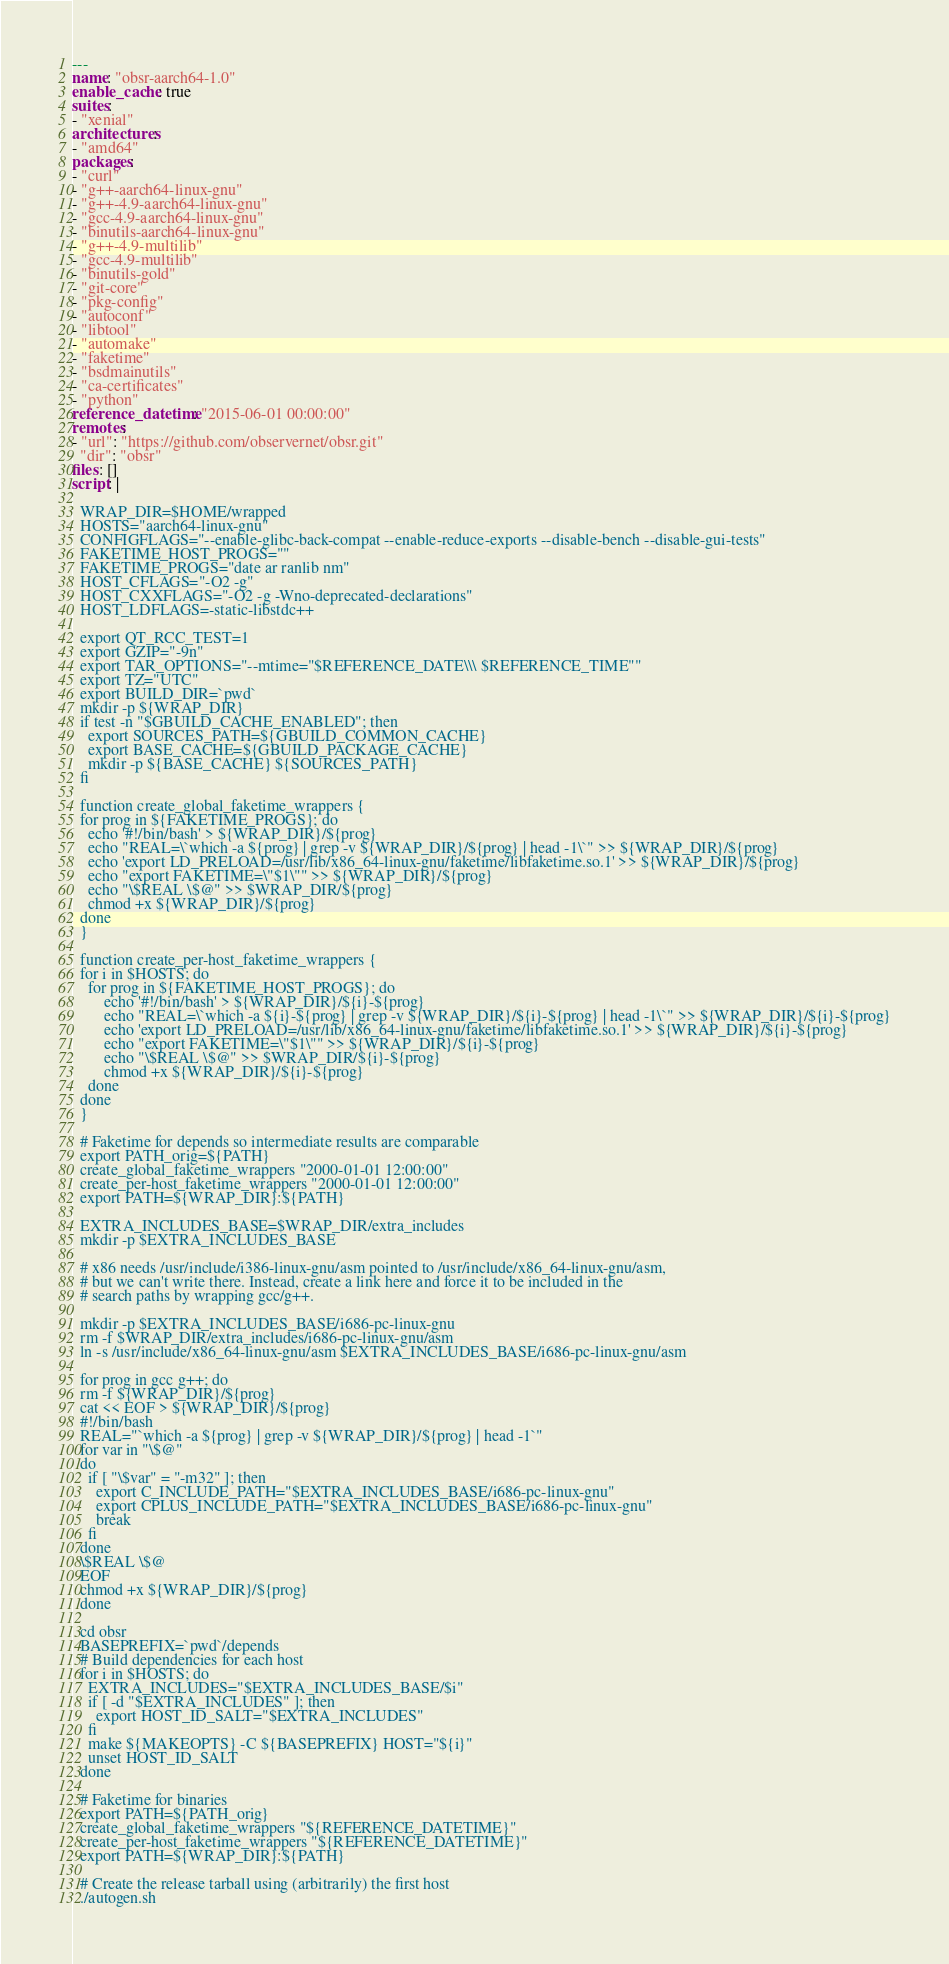<code> <loc_0><loc_0><loc_500><loc_500><_YAML_>---
name: "obsr-aarch64-1.0"
enable_cache: true
suites:
- "xenial"
architectures:
- "amd64"
packages:
- "curl"
- "g++-aarch64-linux-gnu"
- "g++-4.9-aarch64-linux-gnu"
- "gcc-4.9-aarch64-linux-gnu"
- "binutils-aarch64-linux-gnu"
- "g++-4.9-multilib"
- "gcc-4.9-multilib"
- "binutils-gold"
- "git-core"
- "pkg-config"
- "autoconf"
- "libtool"
- "automake"
- "faketime"
- "bsdmainutils"
- "ca-certificates"
- "python"
reference_datetime: "2015-06-01 00:00:00"
remotes:
- "url": "https://github.com/observernet/obsr.git"
  "dir": "obsr"
files: []
script: |

  WRAP_DIR=$HOME/wrapped
  HOSTS="aarch64-linux-gnu"
  CONFIGFLAGS="--enable-glibc-back-compat --enable-reduce-exports --disable-bench --disable-gui-tests"
  FAKETIME_HOST_PROGS=""
  FAKETIME_PROGS="date ar ranlib nm"
  HOST_CFLAGS="-O2 -g"
  HOST_CXXFLAGS="-O2 -g -Wno-deprecated-declarations"
  HOST_LDFLAGS=-static-libstdc++

  export QT_RCC_TEST=1
  export GZIP="-9n"
  export TAR_OPTIONS="--mtime="$REFERENCE_DATE\\\ $REFERENCE_TIME""
  export TZ="UTC"
  export BUILD_DIR=`pwd`
  mkdir -p ${WRAP_DIR}
  if test -n "$GBUILD_CACHE_ENABLED"; then
    export SOURCES_PATH=${GBUILD_COMMON_CACHE}
    export BASE_CACHE=${GBUILD_PACKAGE_CACHE}
    mkdir -p ${BASE_CACHE} ${SOURCES_PATH}
  fi

  function create_global_faketime_wrappers {
  for prog in ${FAKETIME_PROGS}; do
    echo '#!/bin/bash' > ${WRAP_DIR}/${prog}
    echo "REAL=\`which -a ${prog} | grep -v ${WRAP_DIR}/${prog} | head -1\`" >> ${WRAP_DIR}/${prog}
    echo 'export LD_PRELOAD=/usr/lib/x86_64-linux-gnu/faketime/libfaketime.so.1' >> ${WRAP_DIR}/${prog}
    echo "export FAKETIME=\"$1\"" >> ${WRAP_DIR}/${prog}
    echo "\$REAL \$@" >> $WRAP_DIR/${prog}
    chmod +x ${WRAP_DIR}/${prog}
  done
  }

  function create_per-host_faketime_wrappers {
  for i in $HOSTS; do
    for prog in ${FAKETIME_HOST_PROGS}; do
        echo '#!/bin/bash' > ${WRAP_DIR}/${i}-${prog}
        echo "REAL=\`which -a ${i}-${prog} | grep -v ${WRAP_DIR}/${i}-${prog} | head -1\`" >> ${WRAP_DIR}/${i}-${prog}
        echo 'export LD_PRELOAD=/usr/lib/x86_64-linux-gnu/faketime/libfaketime.so.1' >> ${WRAP_DIR}/${i}-${prog}
        echo "export FAKETIME=\"$1\"" >> ${WRAP_DIR}/${i}-${prog}
        echo "\$REAL \$@" >> $WRAP_DIR/${i}-${prog}
        chmod +x ${WRAP_DIR}/${i}-${prog}
    done
  done
  }

  # Faketime for depends so intermediate results are comparable
  export PATH_orig=${PATH}
  create_global_faketime_wrappers "2000-01-01 12:00:00"
  create_per-host_faketime_wrappers "2000-01-01 12:00:00"
  export PATH=${WRAP_DIR}:${PATH}

  EXTRA_INCLUDES_BASE=$WRAP_DIR/extra_includes
  mkdir -p $EXTRA_INCLUDES_BASE

  # x86 needs /usr/include/i386-linux-gnu/asm pointed to /usr/include/x86_64-linux-gnu/asm,
  # but we can't write there. Instead, create a link here and force it to be included in the
  # search paths by wrapping gcc/g++.

  mkdir -p $EXTRA_INCLUDES_BASE/i686-pc-linux-gnu
  rm -f $WRAP_DIR/extra_includes/i686-pc-linux-gnu/asm
  ln -s /usr/include/x86_64-linux-gnu/asm $EXTRA_INCLUDES_BASE/i686-pc-linux-gnu/asm

  for prog in gcc g++; do
  rm -f ${WRAP_DIR}/${prog}
  cat << EOF > ${WRAP_DIR}/${prog}
  #!/bin/bash
  REAL="`which -a ${prog} | grep -v ${WRAP_DIR}/${prog} | head -1`"
  for var in "\$@"
  do
    if [ "\$var" = "-m32" ]; then
      export C_INCLUDE_PATH="$EXTRA_INCLUDES_BASE/i686-pc-linux-gnu"
      export CPLUS_INCLUDE_PATH="$EXTRA_INCLUDES_BASE/i686-pc-linux-gnu"
      break
    fi
  done
  \$REAL \$@
  EOF
  chmod +x ${WRAP_DIR}/${prog}
  done

  cd obsr
  BASEPREFIX=`pwd`/depends
  # Build dependencies for each host
  for i in $HOSTS; do
    EXTRA_INCLUDES="$EXTRA_INCLUDES_BASE/$i"
    if [ -d "$EXTRA_INCLUDES" ]; then
      export HOST_ID_SALT="$EXTRA_INCLUDES"
    fi
    make ${MAKEOPTS} -C ${BASEPREFIX} HOST="${i}"
    unset HOST_ID_SALT
  done

  # Faketime for binaries
  export PATH=${PATH_orig}
  create_global_faketime_wrappers "${REFERENCE_DATETIME}"
  create_per-host_faketime_wrappers "${REFERENCE_DATETIME}"
  export PATH=${WRAP_DIR}:${PATH}

  # Create the release tarball using (arbitrarily) the first host
  ./autogen.sh</code> 